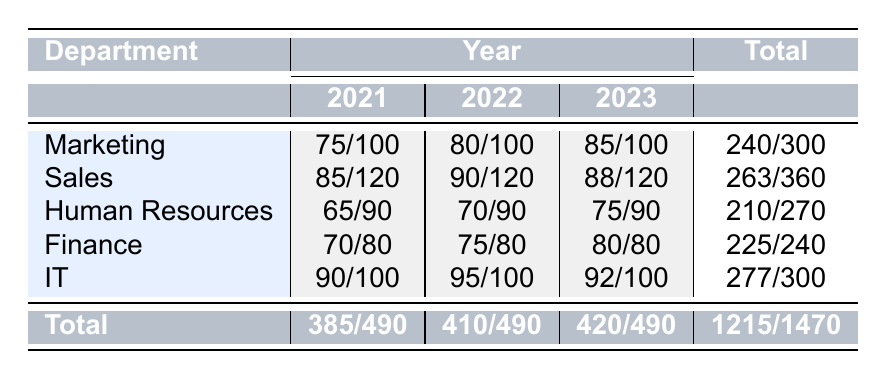What is the total number of attendees from the IT department across all years? From the table, the total attendance from the IT department for each year is 90 (2021) + 95 (2022) + 92 (2023) = 277.
Answer: 277 Which department had the lowest attendance in 2021? In 2021, we check the attended counts: Marketing (75), Sales (85), Human Resources (65), Finance (70), and IT (90). The lowest is Human Resources with 65 attendees.
Answer: Human Resources What was the average attendance rate for the Sales department over the three years? To find the average attendance rate, calculate the total attendance for Sales: (85/120 for 2021) + (90/120 for 2022) + (88/120 for 2023). Sum the attendance numbers (85+90+88) = 263 and total number of meetings (120+120+120) = 360. The average is then 263/360.
Answer: 0.7306 (or 73.06%) Did the attendance in the Finance department improve from 2021 to 2023? We compare the attended numbers for Finance over these years: 70 in 2021, 75 in 2022, and 80 in 2023. Since the numbers increased each year (70 < 75 < 80), the attendance did improve.
Answer: Yes Which year had the highest total attendance across all departments? The total attendance for each year is calculated as follows: 2021 = 385, 2022 = 410, and 2023 = 420. Since 420 (2023) is the highest of the three totals, 2023 had the highest attendance.
Answer: 2023 What percentage of total possible attendees attended meetings in the Human Resources department in 2022? The total attendees for Human Resources in 2022 are 70 out of 90 possible. To find the percentage, calculate (70/90) * 100 = 77.78%.
Answer: 77.78% How many more attendees were there in the IT department in 2022 than in Human Resources in the same year? For IT in 2022, the attendees were 95, and for Human Resources, they were 70. To find the difference, calculate 95 - 70 = 25.
Answer: 25 Which department had the highest total attendance across all years, and what was it? Summing the attendance for all departments gives Marketing (240), Sales (263), Human Resources (210), Finance (225), and IT (277). The highest is IT with a total attendance of 277.
Answer: IT, 277 